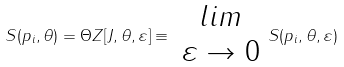Convert formula to latex. <formula><loc_0><loc_0><loc_500><loc_500>S ( p _ { i } , \theta ) = \Theta Z [ J , \theta , \varepsilon ] \equiv \begin{array} { c } l i m \\ \varepsilon \rightarrow 0 \end{array} S ( p _ { i } , \theta , \varepsilon )</formula> 